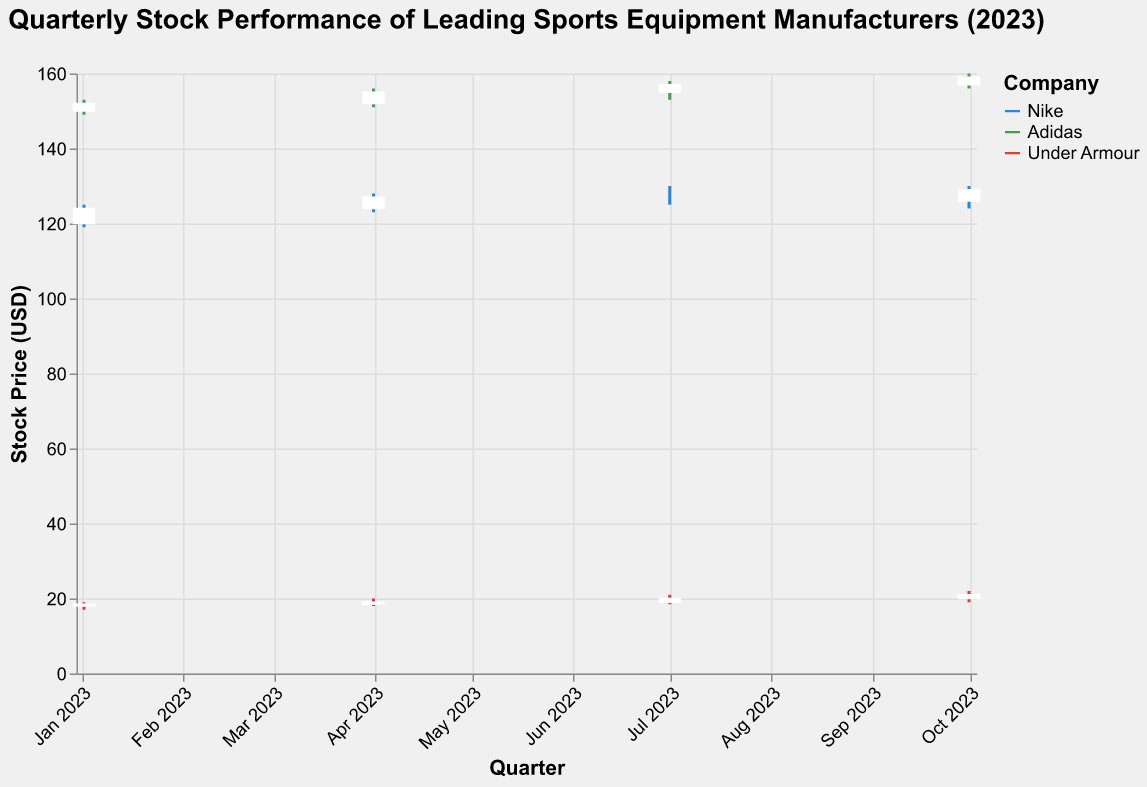What is the title of the figure? The title of the figure is typically displayed at the top and provides a summary of what the figure represents.
Answer: Quarterly Stock Performance of Leading Sports Equipment Manufacturers (2023) Which company had the highest closing price on January 2, 2023? To determine the highest closing price, compare the closing prices of Nike, Adidas, and Under Armour on January 2, 2023. Adidas had the highest closing price of 152.
Answer: Adidas What was the opening price for Nike in the third quarter? Check the opening price for Nike on July 1, 2023. The opening price for Nike in the third quarter is 127.
Answer: 127 How did Adidas' stock price change from the second quarter to the third quarter? Compare the closing price of Adidas on April 1, 2023 (155) to the closing price on July 1, 2023 (157). The change is 157 - 155 = 2.
Answer: Increased by 2 What was the average closing price of Under Armour across all quarters? Sum the closing prices of Under Armour (18.5 + 19 + 20 + 21) and divide by the number of quarters (4): (18.5 + 19 + 20 + 21) / 4 = 19.625.
Answer: 19.625 Which company had the highest trading volume in the fourth quarter? Look at the trading volumes for Nike, Adidas, and Under Armour on October 1, 2023. Nike had the highest trading volume of 3,700,000.
Answer: Nike Did any company's stock price close higher than it opened in all four quarters? Review the opening and closing prices for each company across all quarters. No company’s stock price closed higher than it opened in all four quarters; each had at least one quarter where it closed lower.
Answer: No Which quarter showed the largest increase in closing price for Nike? Compare Nike's closing prices for each quarter and calculate the differences: Q1 (124 to 127, +3), Q2 (127 to 126, -1), Q3 (126 to 129, +3). The largest increase occurred in Q3 with a +3 increase.
Answer: Q3 How did the opening price of Under Armour change from the second quarter to the fourth quarter? Compare the opening price of Under Armour on April 1, 2023 (18.5) to the opening price on October 1, 2023 (20). The change is 20 - 18.5 = 1.5.
Answer: Increased by 1.5 Which company had the smallest range in stock price (High - Low) in the first quarter? Calculate the range for each company's stock price in Q1: Nike (125 - 119 = 6), Adidas (153 - 149 = 4), Under Armour (19 - 17 = 2). Under Armour had the smallest range of 2.
Answer: Under Armour 